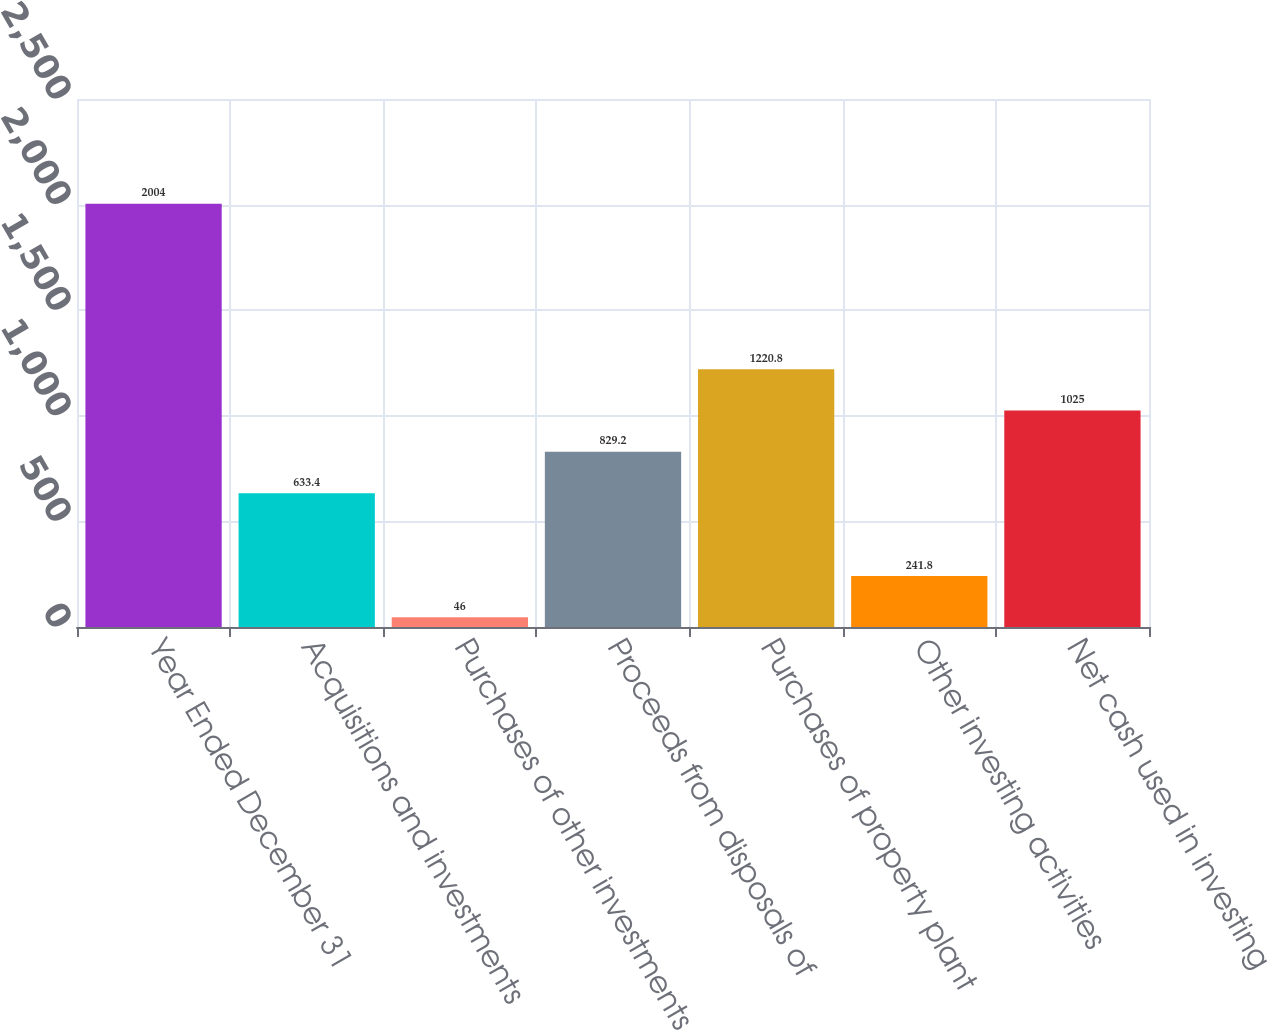Convert chart. <chart><loc_0><loc_0><loc_500><loc_500><bar_chart><fcel>Year Ended December 31<fcel>Acquisitions and investments<fcel>Purchases of other investments<fcel>Proceeds from disposals of<fcel>Purchases of property plant<fcel>Other investing activities<fcel>Net cash used in investing<nl><fcel>2004<fcel>633.4<fcel>46<fcel>829.2<fcel>1220.8<fcel>241.8<fcel>1025<nl></chart> 